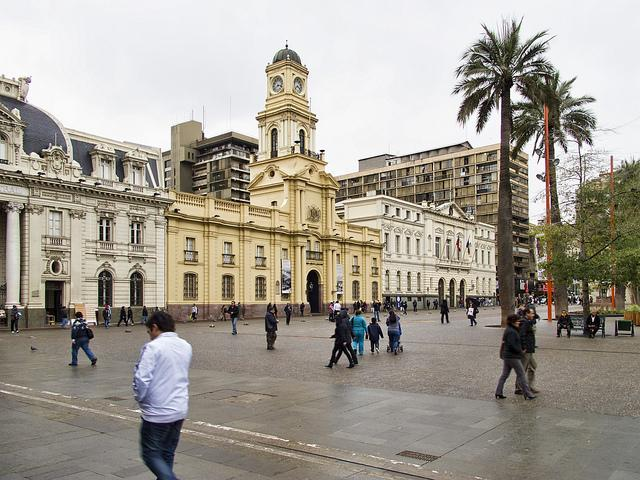What location are people strolling in? Please explain your reasoning. plaza. The people are on an outdoor courtyard. 